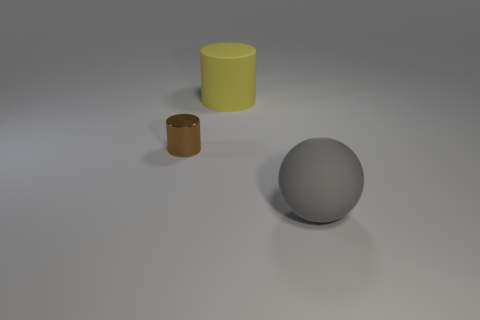Add 2 green cubes. How many objects exist? 5 Subtract all balls. How many objects are left? 2 Add 1 shiny things. How many shiny things are left? 2 Add 1 big matte objects. How many big matte objects exist? 3 Subtract 0 blue cubes. How many objects are left? 3 Subtract all large cylinders. Subtract all big things. How many objects are left? 0 